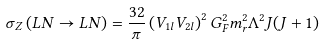<formula> <loc_0><loc_0><loc_500><loc_500>\sigma _ { Z } \left ( L N \rightarrow L N \right ) = \frac { 3 2 } { \pi } \left ( V _ { 1 l } V _ { 2 l } \right ) ^ { 2 } G _ { F } ^ { 2 } m _ { r } ^ { 2 } \Lambda ^ { 2 } J ( J + 1 )</formula> 